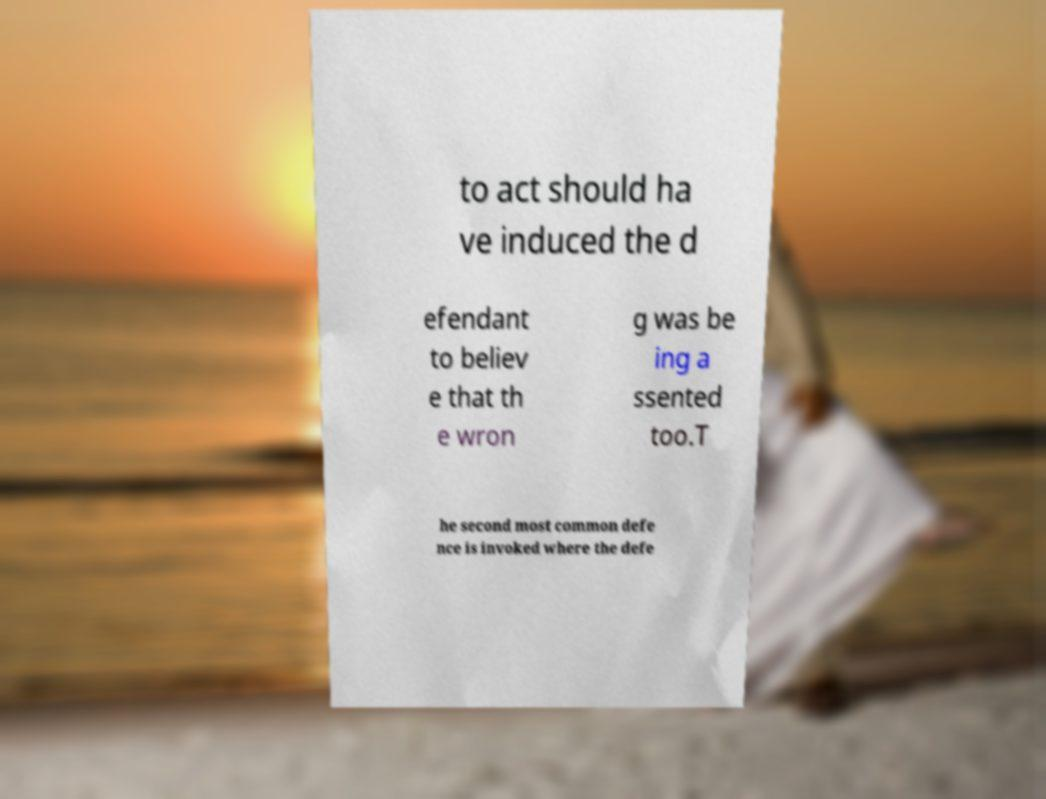Could you extract and type out the text from this image? to act should ha ve induced the d efendant to believ e that th e wron g was be ing a ssented too.T he second most common defe nce is invoked where the defe 